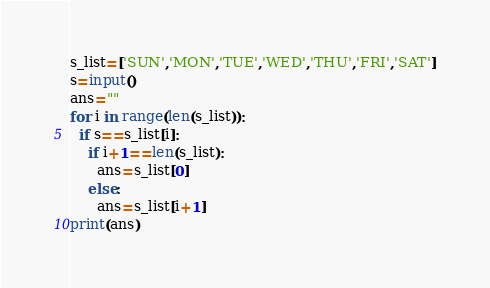<code> <loc_0><loc_0><loc_500><loc_500><_Python_>s_list=['SUN','MON','TUE','WED','THU','FRI','SAT']
s=input()
ans=""
for i in range(len(s_list)):
  if s==s_list[i]:
    if i+1==len(s_list):
      ans=s_list[0]
    else:
      ans=s_list[i+1]
print(ans)</code> 